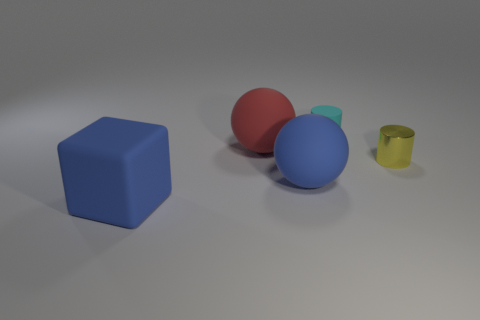Add 4 blue things. How many objects exist? 9 Subtract all large red objects. Subtract all cyan rubber cylinders. How many objects are left? 3 Add 1 large matte balls. How many large matte balls are left? 3 Add 5 tiny yellow metallic cylinders. How many tiny yellow metallic cylinders exist? 6 Subtract 0 red cubes. How many objects are left? 5 Subtract all blocks. How many objects are left? 4 